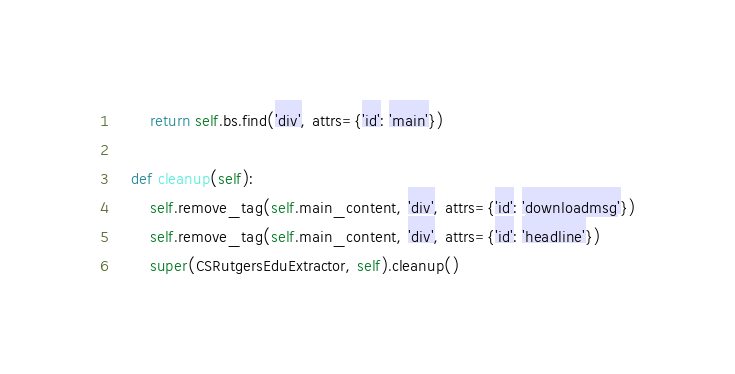<code> <loc_0><loc_0><loc_500><loc_500><_Python_>        return self.bs.find('div', attrs={'id': 'main'})

    def cleanup(self):
        self.remove_tag(self.main_content, 'div', attrs={'id': 'downloadmsg'})
        self.remove_tag(self.main_content, 'div', attrs={'id': 'headline'})
        super(CSRutgersEduExtractor, self).cleanup()
</code> 